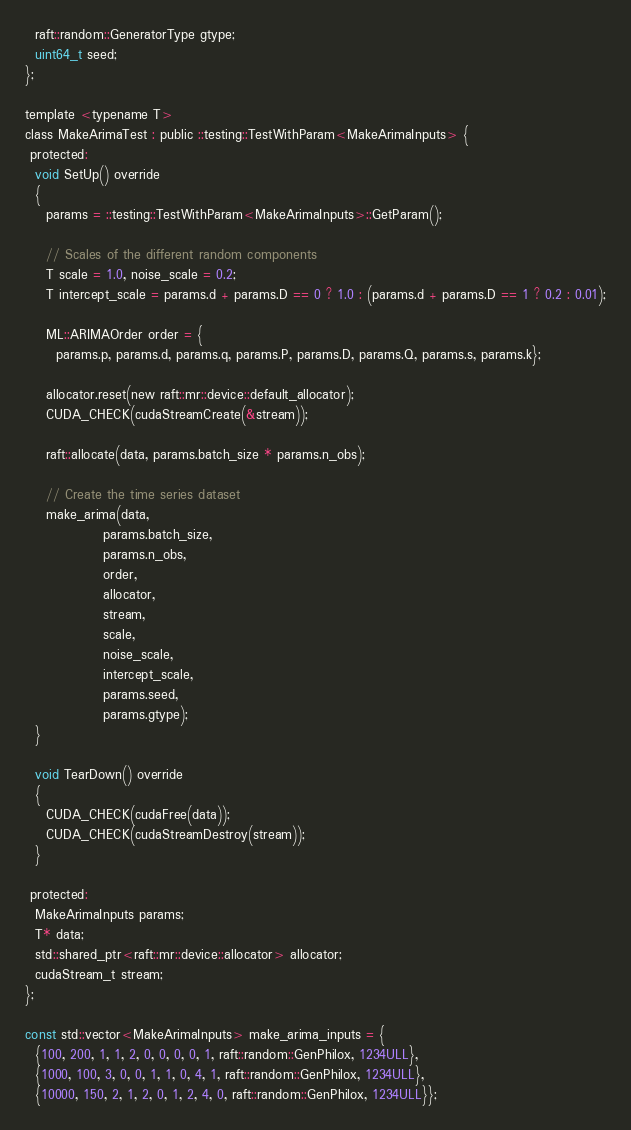<code> <loc_0><loc_0><loc_500><loc_500><_Cuda_>  raft::random::GeneratorType gtype;
  uint64_t seed;
};

template <typename T>
class MakeArimaTest : public ::testing::TestWithParam<MakeArimaInputs> {
 protected:
  void SetUp() override
  {
    params = ::testing::TestWithParam<MakeArimaInputs>::GetParam();

    // Scales of the different random components
    T scale = 1.0, noise_scale = 0.2;
    T intercept_scale = params.d + params.D == 0 ? 1.0 : (params.d + params.D == 1 ? 0.2 : 0.01);

    ML::ARIMAOrder order = {
      params.p, params.d, params.q, params.P, params.D, params.Q, params.s, params.k};

    allocator.reset(new raft::mr::device::default_allocator);
    CUDA_CHECK(cudaStreamCreate(&stream));

    raft::allocate(data, params.batch_size * params.n_obs);

    // Create the time series dataset
    make_arima(data,
               params.batch_size,
               params.n_obs,
               order,
               allocator,
               stream,
               scale,
               noise_scale,
               intercept_scale,
               params.seed,
               params.gtype);
  }

  void TearDown() override
  {
    CUDA_CHECK(cudaFree(data));
    CUDA_CHECK(cudaStreamDestroy(stream));
  }

 protected:
  MakeArimaInputs params;
  T* data;
  std::shared_ptr<raft::mr::device::allocator> allocator;
  cudaStream_t stream;
};

const std::vector<MakeArimaInputs> make_arima_inputs = {
  {100, 200, 1, 1, 2, 0, 0, 0, 0, 1, raft::random::GenPhilox, 1234ULL},
  {1000, 100, 3, 0, 0, 1, 1, 0, 4, 1, raft::random::GenPhilox, 1234ULL},
  {10000, 150, 2, 1, 2, 0, 1, 2, 4, 0, raft::random::GenPhilox, 1234ULL}};
</code> 